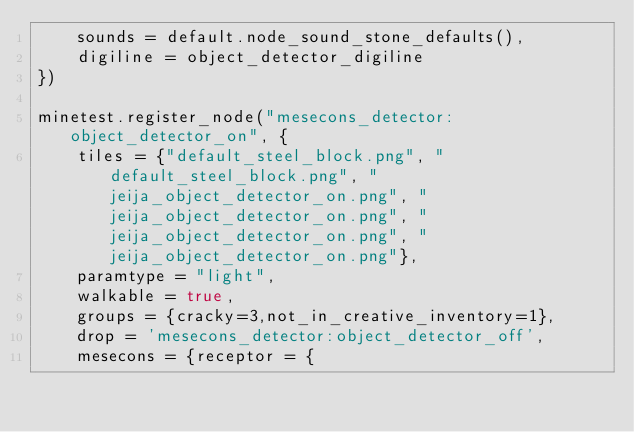Convert code to text. <code><loc_0><loc_0><loc_500><loc_500><_Lua_>	sounds = default.node_sound_stone_defaults(),
	digiline = object_detector_digiline
})

minetest.register_node("mesecons_detector:object_detector_on", {
	tiles = {"default_steel_block.png", "default_steel_block.png", "jeija_object_detector_on.png", "jeija_object_detector_on.png", "jeija_object_detector_on.png", "jeija_object_detector_on.png"},
	paramtype = "light",
	walkable = true,
	groups = {cracky=3,not_in_creative_inventory=1},
	drop = 'mesecons_detector:object_detector_off',
	mesecons = {receptor = {</code> 